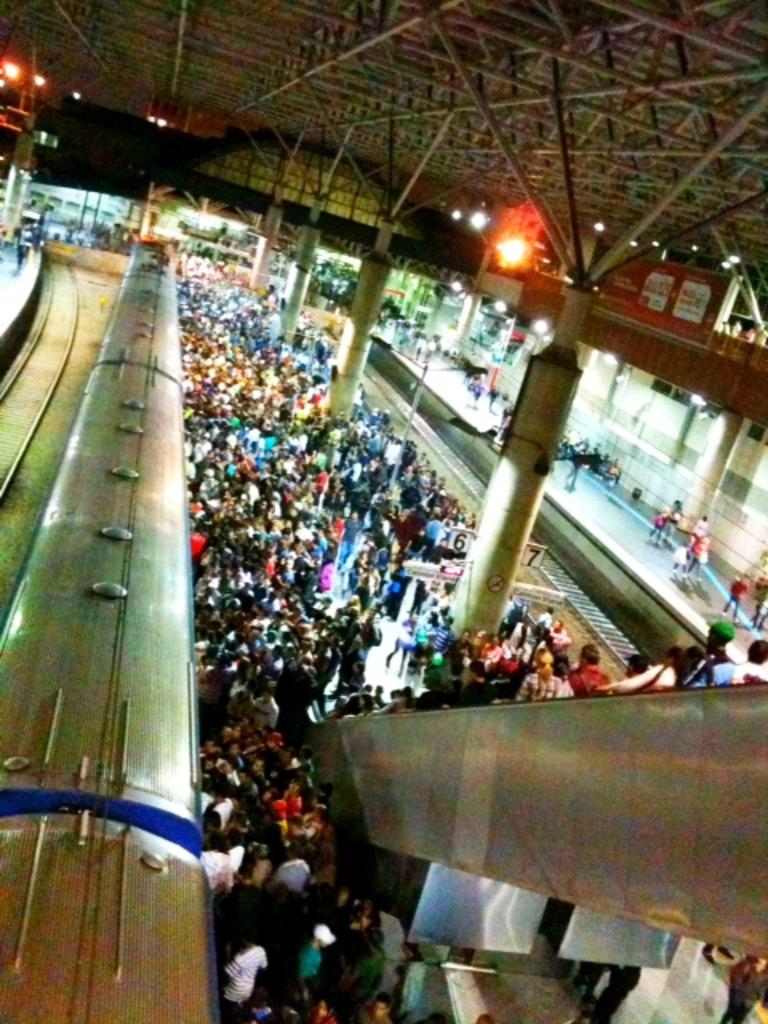How many people are in the group visible in the image? The image shows a group of people, but the exact number cannot be determined from the provided facts. What can be seen illuminated in the image? There are lights visible in the image. What mode of transportation is present in the image? There is a train in the image. What type of infrastructure is associated with the train in the image? There is a railway track in the image. What type of structures are visible in the image? There are buildings in the image. What type of dinner is being prepared by the cook in the image? There is no cook or dinner preparation visible in the image. What type of destruction can be seen in the image? There is no destruction present in the image. 